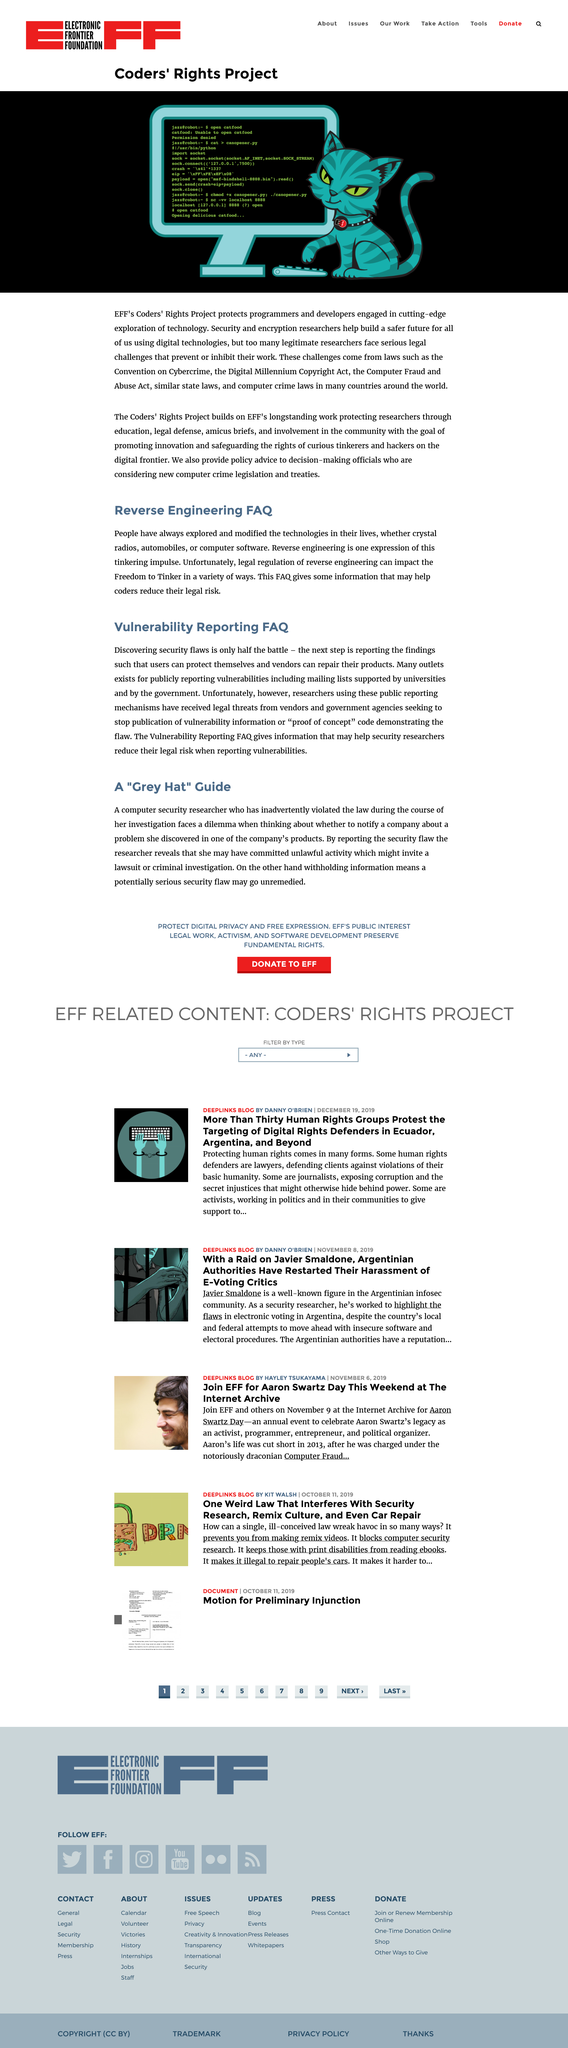Indicate a few pertinent items in this graphic. The Coders' Rights Project was created by the Electronic Frontier Foundation (EFF). People have always explored and modified the technology in their lives. The aim of security and encryption researchers is to help build a safer future for all by developing and improving techniques for protecting digital information and communication from unauthorized access or manipulation. Laws such as the Convention on Cybercrime, the Digital Millennium Copyright Act, the Computer Fraud and Abuse Act, and similar state and computer crime laws often prevent or inhibit security and encryption researchers. Discovering security flaws is only half the battle; the real challenge lies in addressing and mitigating them effectively. 